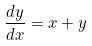<formula> <loc_0><loc_0><loc_500><loc_500>\frac { d y } { d x } = x + y</formula> 